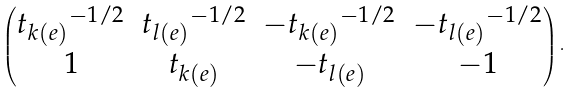<formula> <loc_0><loc_0><loc_500><loc_500>\begin{pmatrix} { t _ { k ( e ) } } ^ { - 1 / 2 } & { t _ { l ( e ) } } ^ { - 1 / 2 } & - { t _ { k ( e ) } } ^ { - 1 / 2 } & - { t _ { l ( e ) } } ^ { - 1 / 2 } \\ 1 & t _ { k ( e ) } & - t _ { l ( e ) } & - 1 \end{pmatrix} .</formula> 